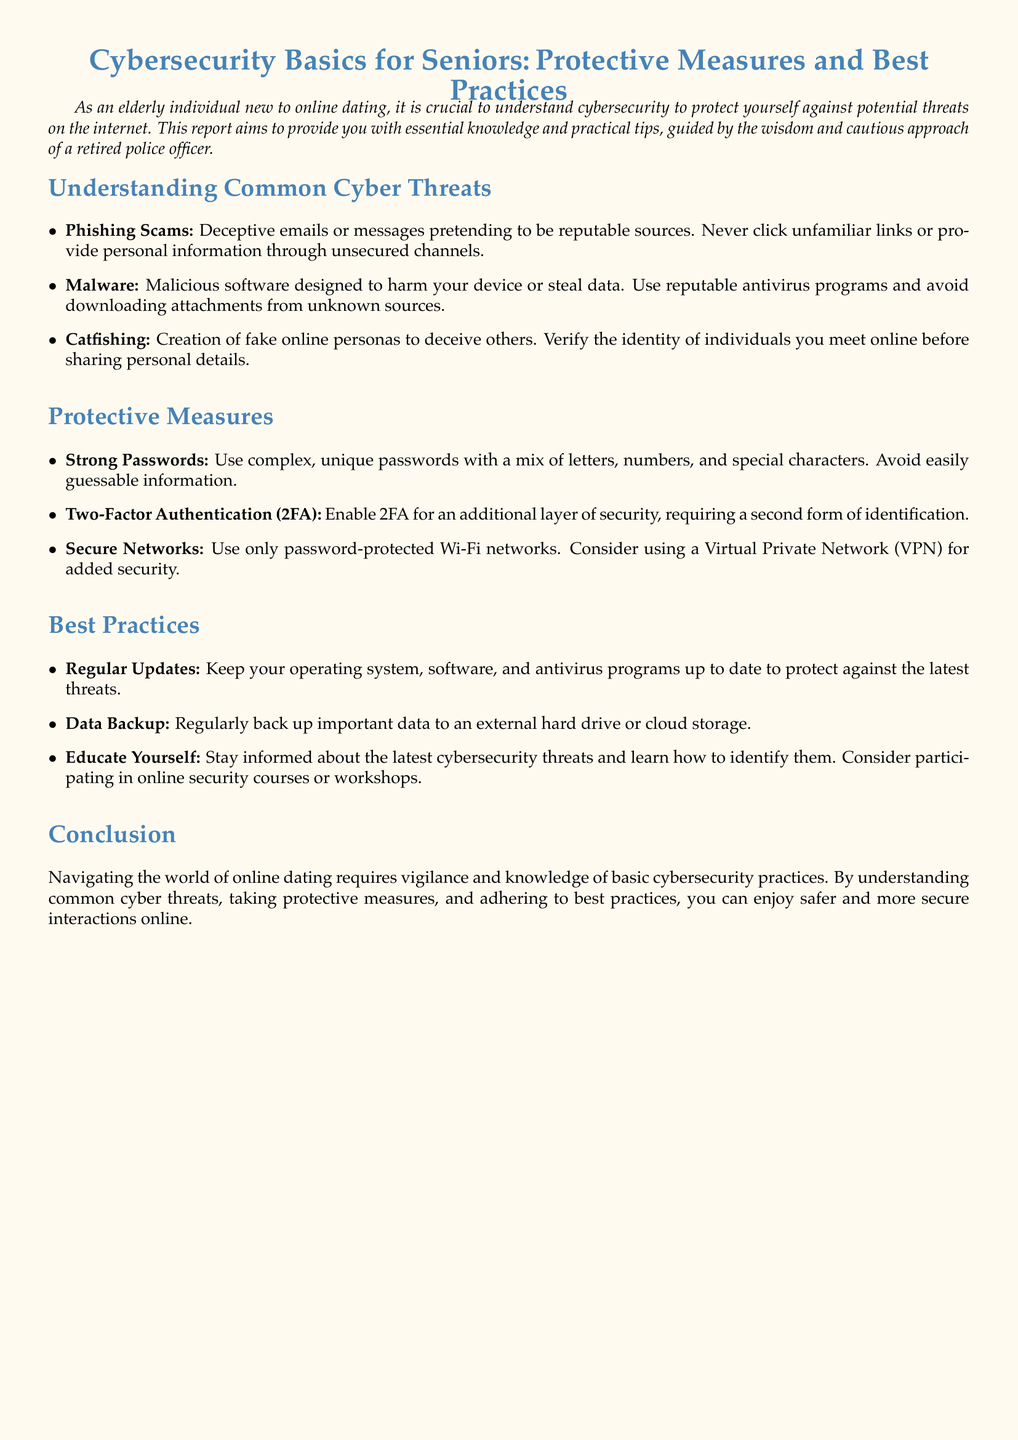What are phishing scams? Phishing scams are deceptive emails or messages pretending to be reputable sources.
Answer: Deceptive emails What is one example of a protective measure? The document lists multiple protective measures, one being the use of strong passwords.
Answer: Strong passwords What does 2FA stand for? The document mentions 2FA as an additional layer of security, indicating it stands for two-factor authentication.
Answer: Two-factor authentication What is a risk of catfishing? The document states catfishing involves the creation of fake online personas to deceive others.
Answer: Deceive others What should you regularly back up? According to the document, you should regularly back up important data.
Answer: Important data What type of programs should you keep updated? The document advises keeping antivirus programs up to date.
Answer: Antivirus programs What is one way to educate yourself about cybersecurity? The document suggests participating in online security courses or workshops.
Answer: Online security courses What is the main purpose of the document? The document provides essential knowledge and practical tips for seniors regarding cybersecurity.
Answer: Essential knowledge What color is used for the main title? The color used for the main title in the document is described in RGB format, which indicates a specific shade.
Answer: Maincolor 